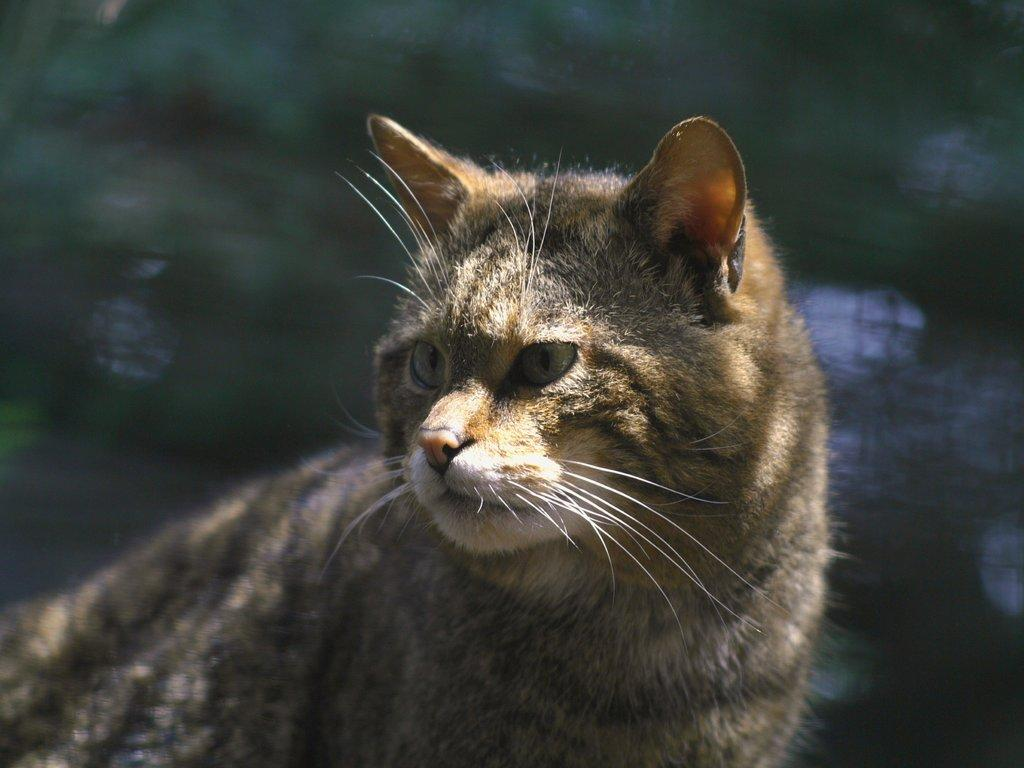What type of animal is in the image? There is a cat in the image. Can you describe the color pattern of the cat? The cat is white, black, and brown in color. How is the cat positioned in the image? The cat is blurred in the background. What type of act is the monkey performing in the image? There is no monkey present in the image, so it is not possible to answer that question. 